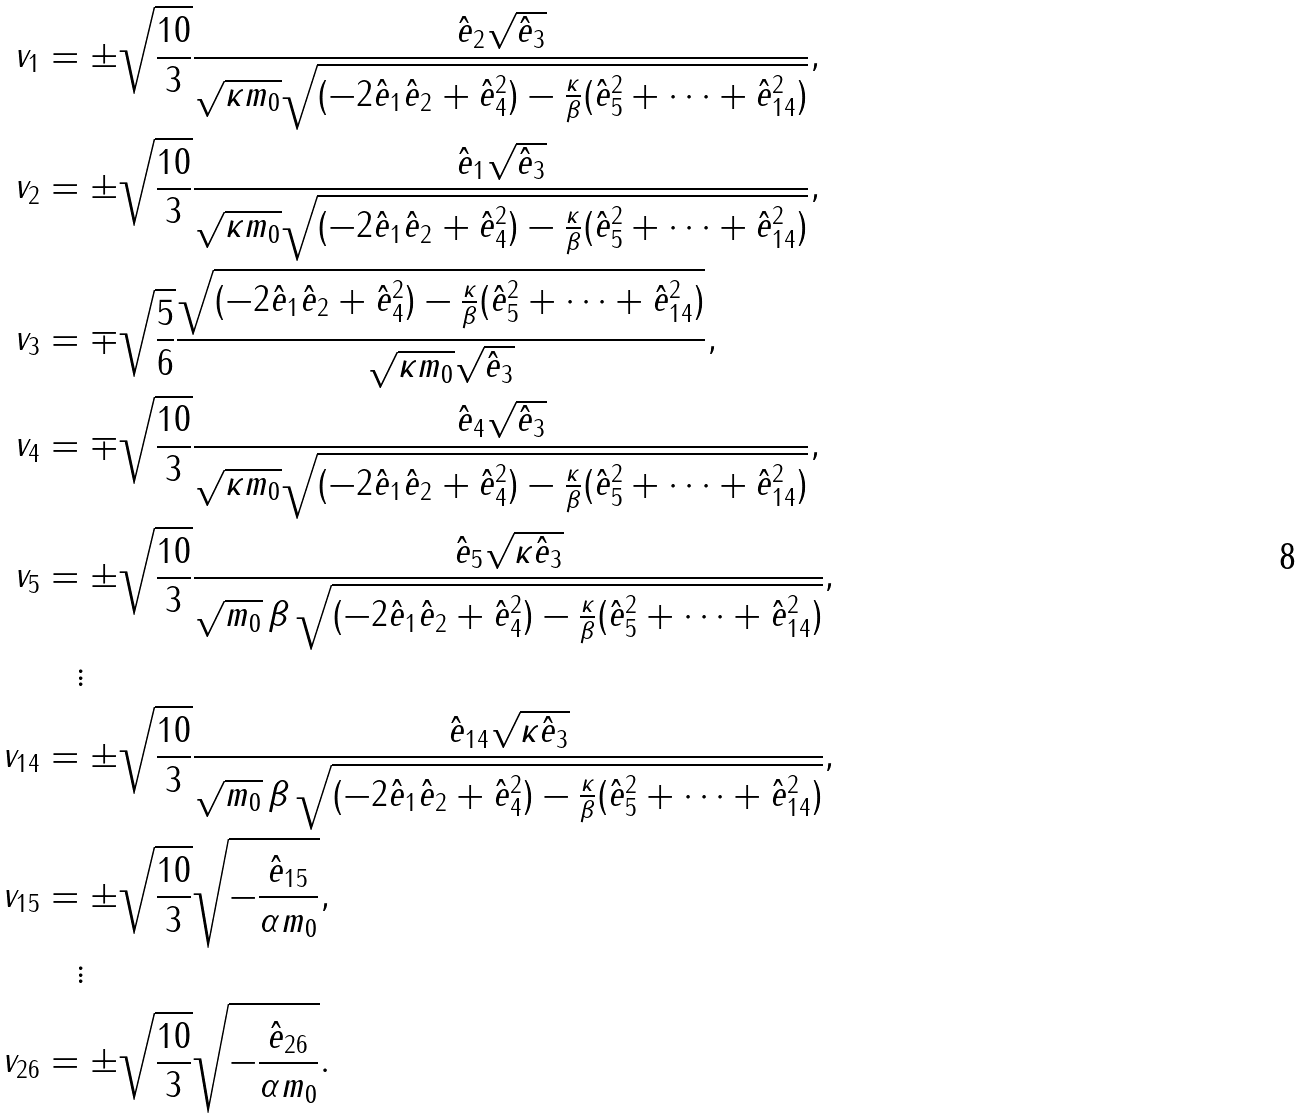Convert formula to latex. <formula><loc_0><loc_0><loc_500><loc_500>v _ { 1 } & = \pm \sqrt { \frac { 1 0 } { 3 } } \frac { \hat { e } _ { 2 } \sqrt { \hat { e } _ { 3 } } } { \sqrt { \kappa m _ { 0 } } \sqrt { ( - 2 \hat { e } _ { 1 } \hat { e } _ { 2 } + { \hat { e } _ { 4 } } ^ { 2 } ) - \frac { \kappa } { \beta } ( { \hat { e } _ { 5 } } ^ { 2 } + \dots + { \hat { e } _ { 1 4 } } ^ { 2 } ) } } , \\ v _ { 2 } & = \pm \sqrt { \frac { 1 0 } { 3 } } \frac { \hat { e } _ { 1 } \sqrt { \hat { e } _ { 3 } } } { \sqrt { \kappa m _ { 0 } } \sqrt { ( - 2 \hat { e } _ { 1 } \hat { e } _ { 2 } + { \hat { e } _ { 4 } } ^ { 2 } ) - \frac { \kappa } { \beta } ( { \hat { e } _ { 5 } } ^ { 2 } + \dots + { \hat { e } _ { 1 4 } } ^ { 2 } ) } } , \\ v _ { 3 } & = \mp \sqrt { \frac { 5 } { 6 } } \frac { \sqrt { ( - 2 \hat { e } _ { 1 } \hat { e } _ { 2 } + { \hat { e } _ { 4 } } ^ { 2 } ) - \frac { \kappa } { \beta } ( { \hat { e } _ { 5 } } ^ { 2 } + \dots + { \hat { e } _ { 1 4 } } ^ { 2 } ) } } { \sqrt { \kappa m _ { 0 } } \sqrt { \hat { e } _ { 3 } } } , \\ v _ { 4 } & = \mp \sqrt { \frac { 1 0 } { 3 } } \frac { \hat { e } _ { 4 } \sqrt { \hat { e } _ { 3 } } } { \sqrt { \kappa m _ { 0 } } \sqrt { ( - 2 \hat { e } _ { 1 } \hat { e } _ { 2 } + { \hat { e } _ { 4 } } ^ { 2 } ) - \frac { \kappa } { \beta } ( { \hat { e } _ { 5 } } ^ { 2 } + \dots + { \hat { e } _ { 1 4 } } ^ { 2 } ) } } , \\ v _ { 5 } & = \pm \sqrt { \frac { 1 0 } { 3 } } \frac { \hat { e } _ { 5 } \sqrt { \kappa \hat { e } _ { 3 } } } { \sqrt { m _ { 0 } } \, \beta \, \sqrt { ( - 2 \hat { e } _ { 1 } \hat { e } _ { 2 } + { \hat { e } _ { 4 } } ^ { 2 } ) - \frac { \kappa } { \beta } ( { \hat { e } _ { 5 } } ^ { 2 } + \dots + { \hat { e } _ { 1 4 } } ^ { 2 } ) } } , \\ & \quad \vdots \\ v _ { 1 4 } & = \pm \sqrt { \frac { 1 0 } { 3 } } \frac { \hat { e } _ { 1 4 } \sqrt { \kappa \hat { e } _ { 3 } } } { \sqrt { m _ { 0 } } \, \beta \, \sqrt { ( - 2 \hat { e } _ { 1 } \hat { e } _ { 2 } + { \hat { e } _ { 4 } } ^ { 2 } ) - \frac { \kappa } { \beta } ( { \hat { e } _ { 5 } } ^ { 2 } + \dots + { \hat { e } _ { 1 4 } } ^ { 2 } ) } } , \\ v _ { 1 5 } & = \pm \sqrt { \frac { 1 0 } { 3 } } \sqrt { - \frac { \hat { e } _ { 1 5 } } { \alpha m _ { 0 } } } , \\ & \quad \vdots \\ v _ { 2 6 } & = \pm \sqrt { \frac { 1 0 } { 3 } } \sqrt { - \frac { \hat { e } _ { 2 6 } } { \alpha m _ { 0 } } } .</formula> 